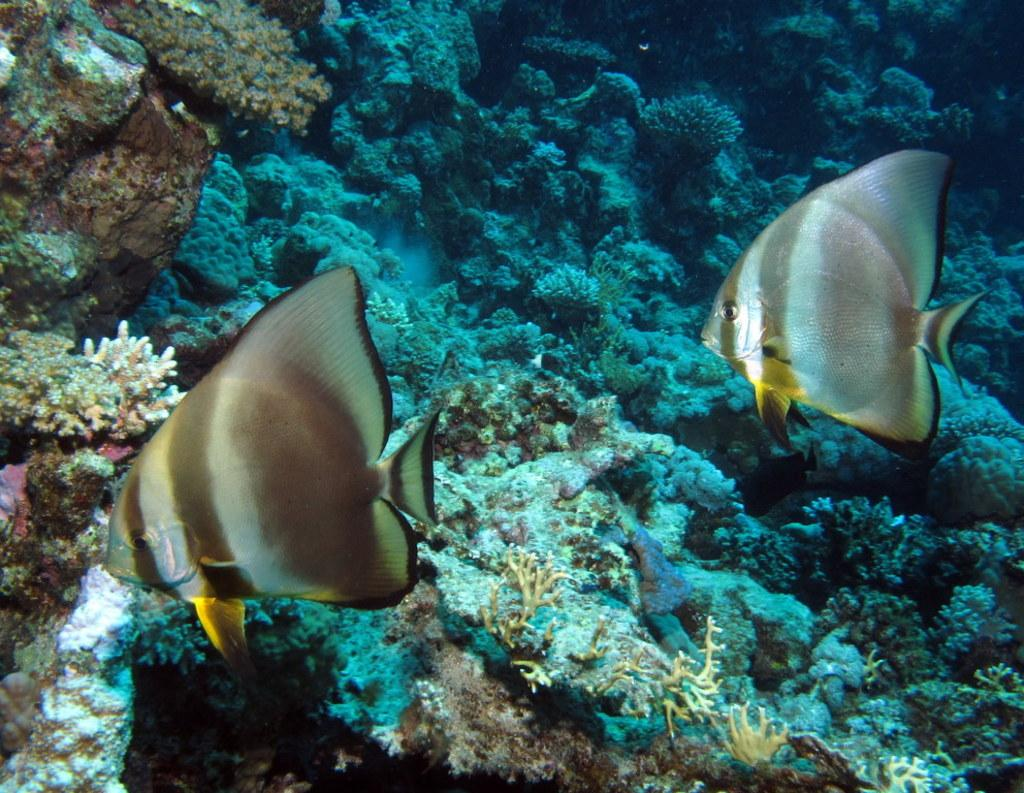What type of animals can be seen in the image? There are fishes visible under the water in the image. What other objects or features can be seen in the image? There are corals in the image. What type of skirt is being worn by the fish in the image? There are no skirts present in the image, as it features fishes and corals underwater. Can you read the letter that the coral is holding in the image? There are no letters or any form of writing present in the image, as it is a natural underwater scene. 